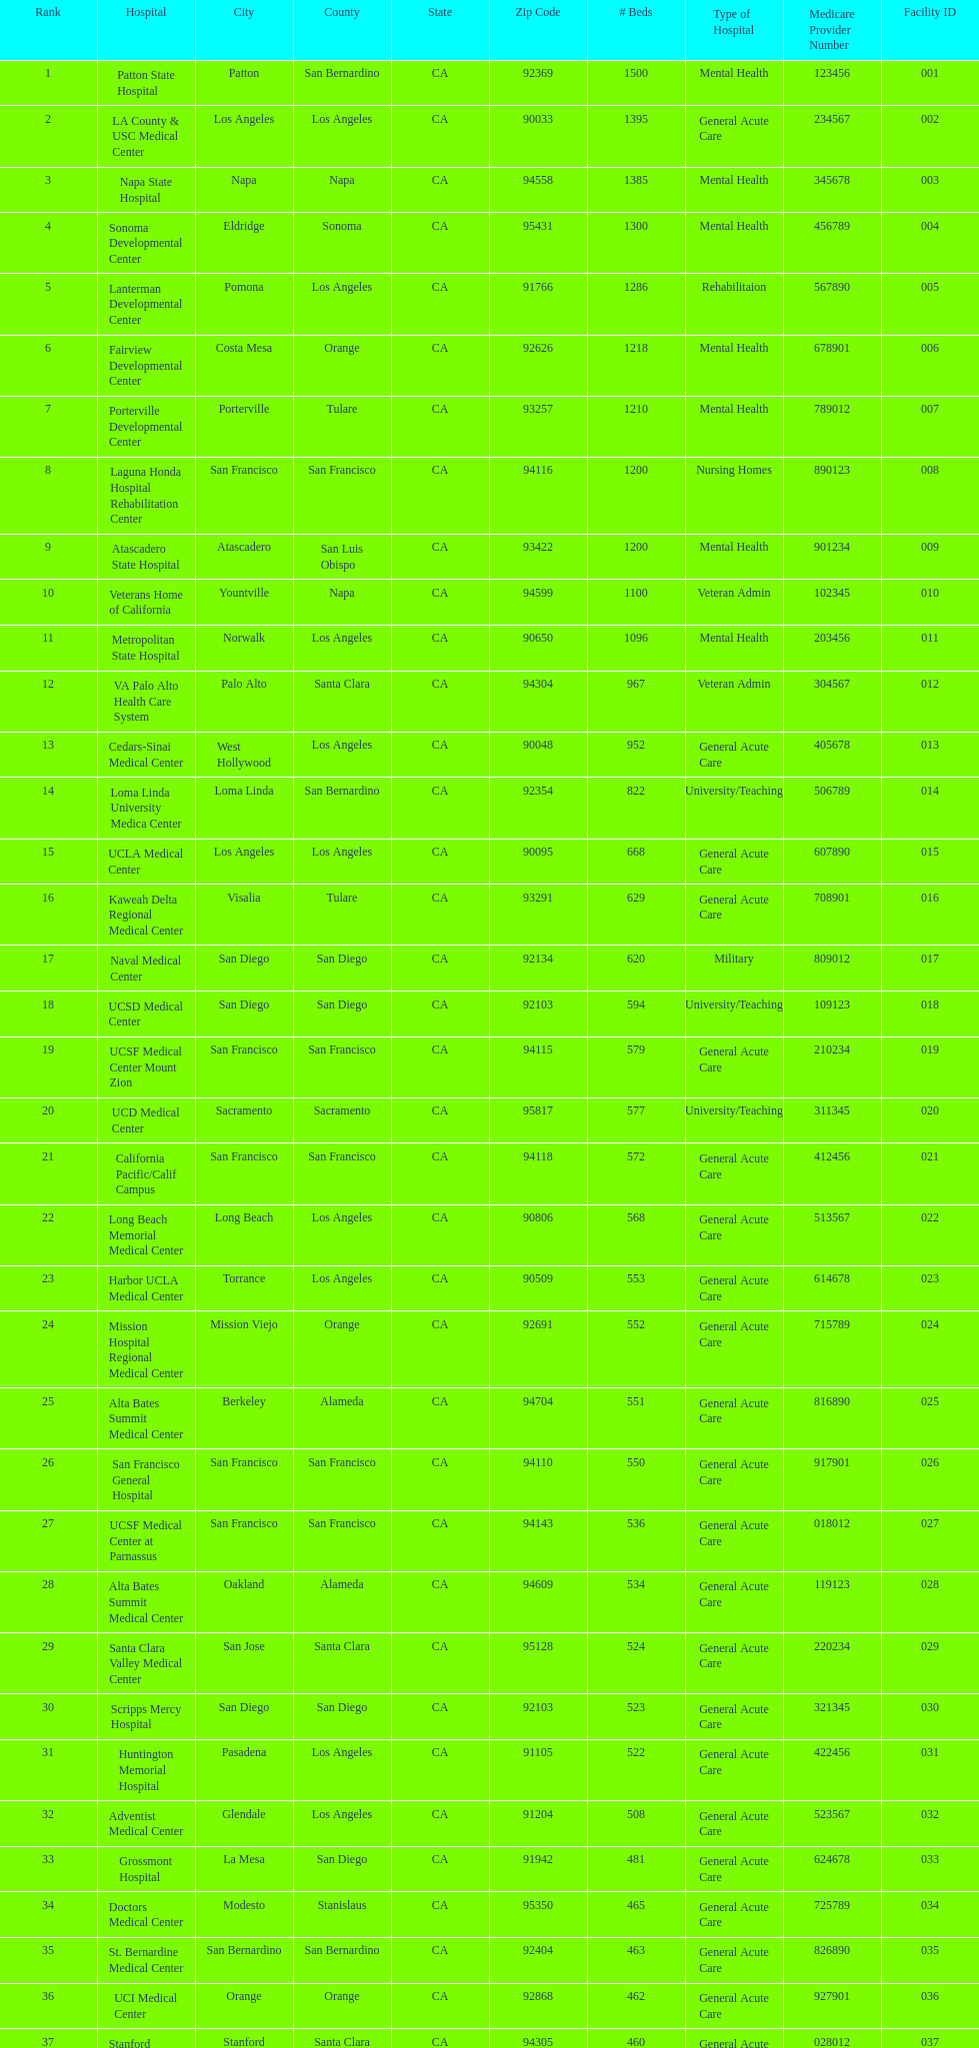How much larger (in number of beds) was the largest hospital in california than the 50th largest? 1071. 